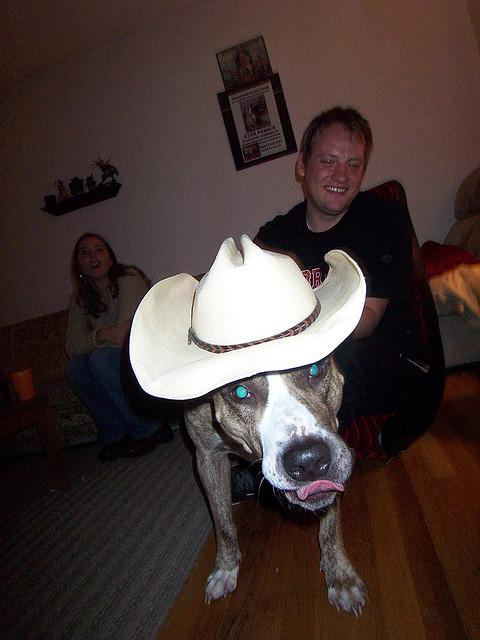Who put the hat on the dog? Please explain your reasoning. man behind. A man sits behind a dog who has a cowboy hat on. the man is smiling. 